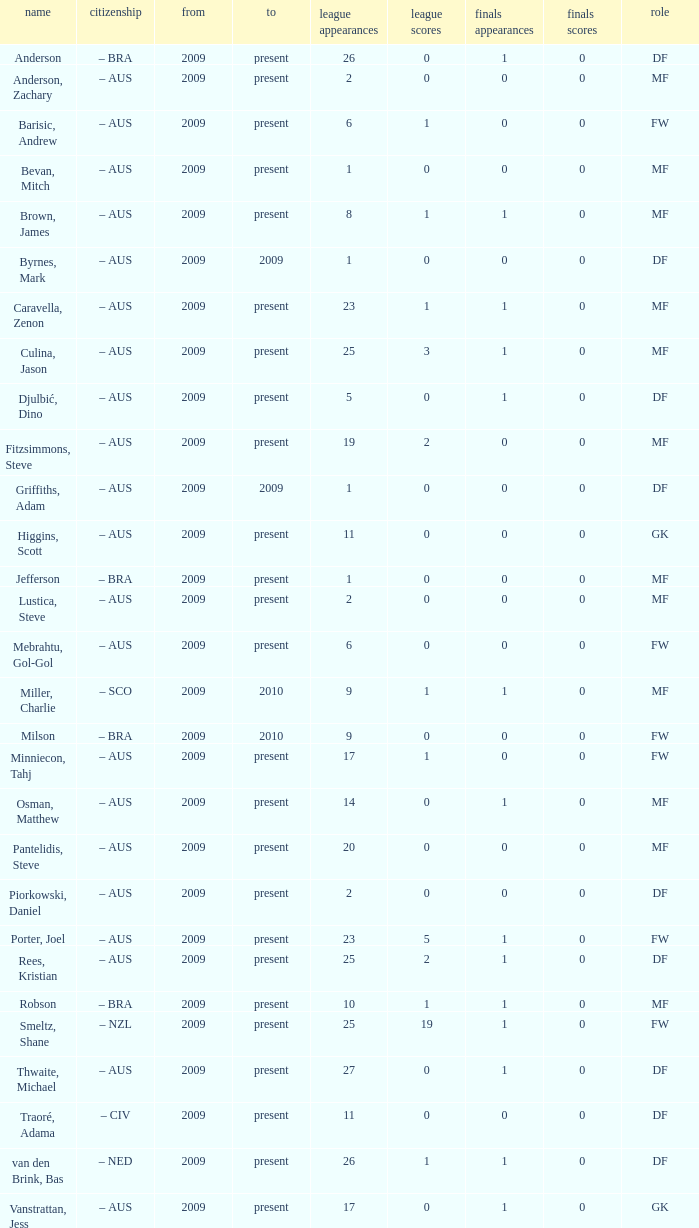Name the mosst finals apps 1.0. 